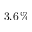Convert formula to latex. <formula><loc_0><loc_0><loc_500><loc_500>3 . 6 \, \%</formula> 